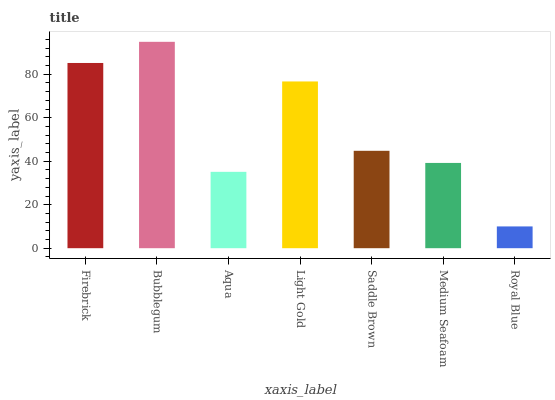Is Aqua the minimum?
Answer yes or no. No. Is Aqua the maximum?
Answer yes or no. No. Is Bubblegum greater than Aqua?
Answer yes or no. Yes. Is Aqua less than Bubblegum?
Answer yes or no. Yes. Is Aqua greater than Bubblegum?
Answer yes or no. No. Is Bubblegum less than Aqua?
Answer yes or no. No. Is Saddle Brown the high median?
Answer yes or no. Yes. Is Saddle Brown the low median?
Answer yes or no. Yes. Is Aqua the high median?
Answer yes or no. No. Is Firebrick the low median?
Answer yes or no. No. 